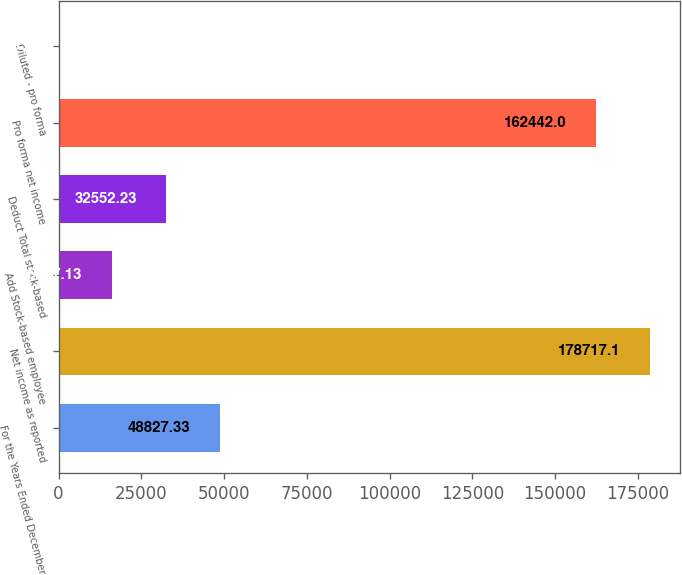Convert chart to OTSL. <chart><loc_0><loc_0><loc_500><loc_500><bar_chart><fcel>For the Years Ended December<fcel>Net income as reported<fcel>Add Stock-based employee<fcel>Deduct Total stock-based<fcel>Pro forma net income<fcel>Diluted - pro forma<nl><fcel>48827.3<fcel>178717<fcel>16277.1<fcel>32552.2<fcel>162442<fcel>2.03<nl></chart> 